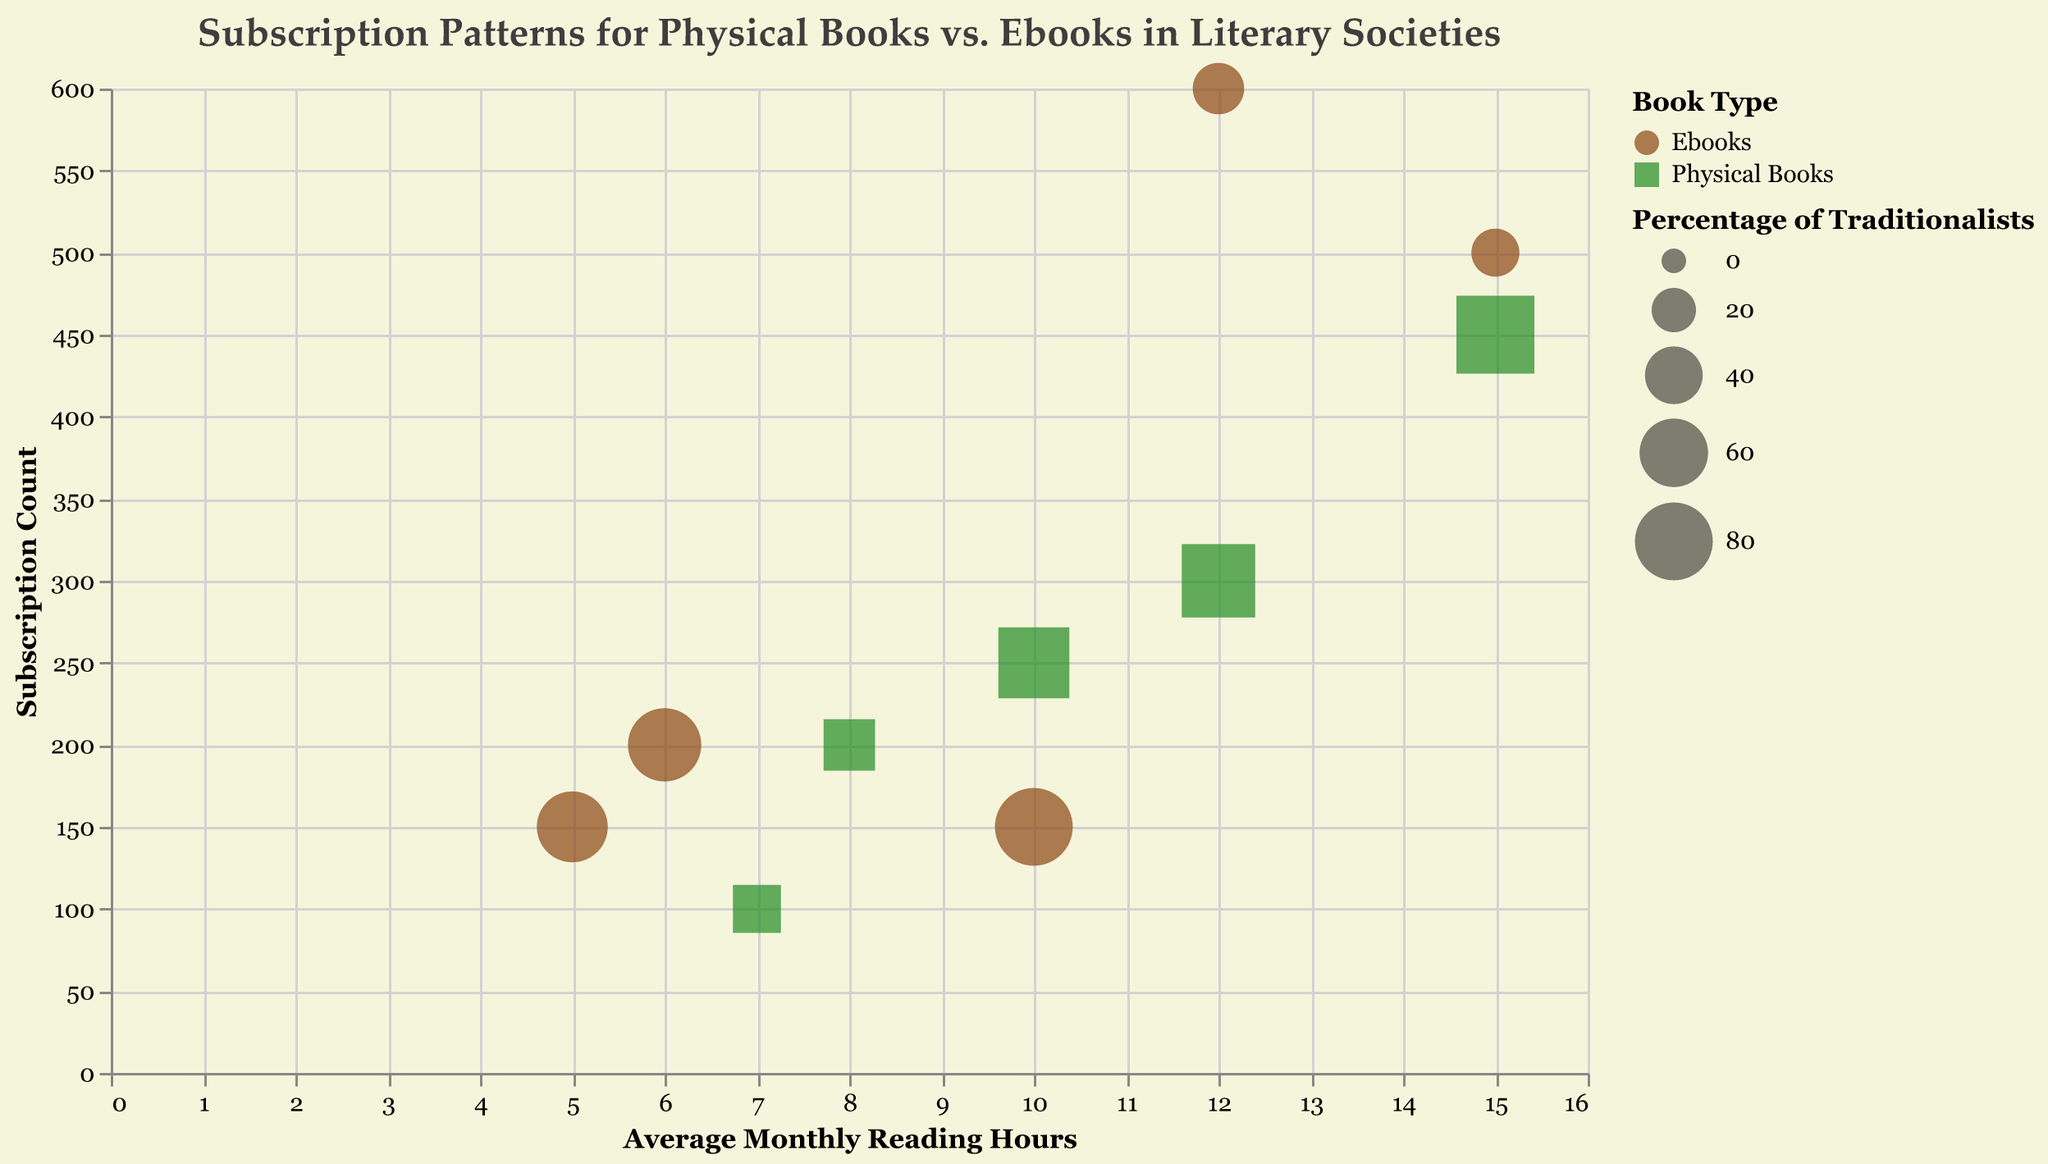What's the title of the chart? The title is typically displayed at the top of the chart, where it clearly states the subject matter. In this case, it informs viewers that the data concerns subscription patterns for physical books vs. ebooks in various literary societies.
Answer: Subscription Patterns for Physical Books vs. Ebooks in Literary Societies Which literary society has the highest subscription count for physical books? To find this, look for the bubble with the highest 'Subscription Count' value among the ones representing physical books. The circle representing "Classic Literature Enthusiasts" for physical books is the largest bubble among physical books.
Answer: Classic Literature Enthusiasts What is the average monthly reading hours for "Science Fiction Clubs" who prefer ebooks? Identify the bubble representing "Science Fiction Clubs" for ebooks, and then check the associated value for 'Average Monthly Reading Hours'. According to the bubble, it is 15 hours.
Answer: 15 hours How many data points represent literary societies that have more subscriptions for ebooks than physical books? Compare the subscription counts for physical books and ebooks within each literary society and count how many societies have higher counts for ebooks. The "Modern Reader Society" and "Science Fiction Clubs" have more subscriptions for ebooks.
Answer: 2 What is the percentage of traditionalists in "Poetry Appreciation Circle" who subscribe to physical books? Locate the bubble representing "Poetry Appreciation Circle" for physical books and then check the associated value for 'Percentage of Traditionalists', which is 65%.
Answer: 65% Compare the subscription count for physical books between "Historical Fiction Lovers" and "Poetry Appreciation Circle". Which is higher? Look at the subscription counts for physical books of both societies and determine which number is higher. Historical Fiction Lovers have 300 subscriptions, whereas Poetry Appreciation Circle has 250.
Answer: Historical Fiction Lovers Which literary society has the highest percentage of traditionalists regardless of book type? Check the size of the bubbles corresponding to the societies. The "Classic Literature Enthusiasts" have the largest bubbles, indicating the highest percentage of traditionalists at 80%.
Answer: Classic Literature Enthusiasts For "Historical Fiction Lovers", how does the average monthly reading hours compare between those who read physical books and those who read ebooks? Compare the 'Average Monthly Reading Hours' of physical books to that of ebooks for the society in question. Physical books read for 12 hours monthly on average, while ebooks read for 6 hours.
Answer: Physical books (12 hours) read more than ebooks (6 hours) Which book type among all societies has larger subscription counts on average: physical books or ebooks? Sum the subscription counts for each book type and divide by the number of societies/points for each type. The total for physical books is 1300 and there are 5 societies, averaging to 260. For ebooks, the total is 1600, averaging to 320.
Answer: Ebooks What is the combined subscription count for all literary societies that prefer ebooks? Add the subscription counts of all societies for ebooks. The counts are: 150, 600, 200, 500, 150. Summing these, the combined count is 1600.
Answer: 1600 